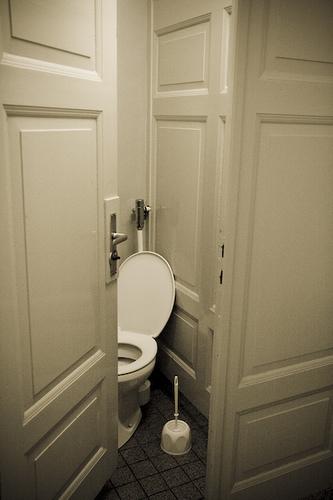Does the picture have a white brush in it?
Quick response, please. Yes. Is the toilet in use?
Quick response, please. No. Is there anything other than a toilet in there?
Give a very brief answer. Yes. 